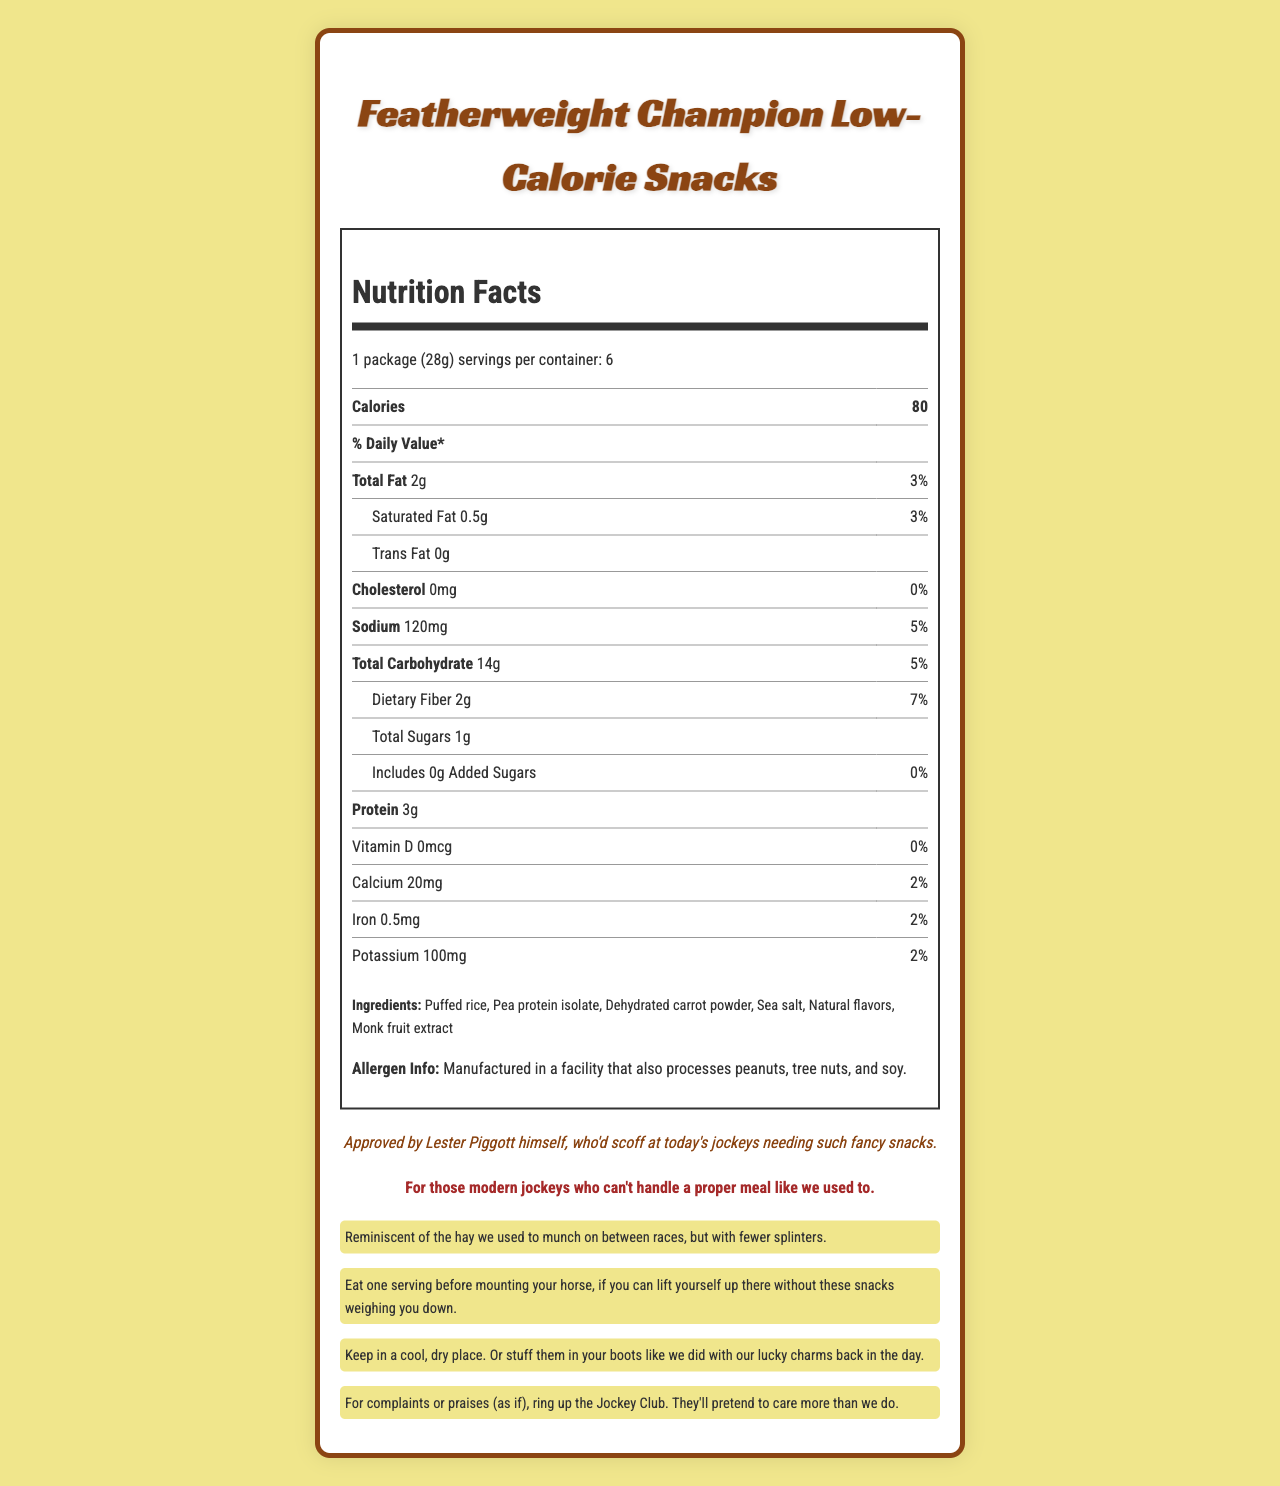who approved these low-calorie snacks? The document states, "Approved by Lester Piggott himself."
Answer: Lester Piggott how many servings are in one container? The document states that there are 6 servings per container.
Answer: 6 servings what is the serving size for these snacks? The document specifies the serving size as "1 package (28g)."
Answer: 1 package (28g) how much sodium is in one serving? The document lists the sodium content of one serving as 120mg.
Answer: 120mg what is the total fat content per serving? According to the document, the total fat content per serving is 2g.
Answer: 2g how much dietary fiber is in one serving of these snacks? The document states that one serving contains 2g of dietary fiber.
Answer: 2g how many calories are in one serving? The document lists the calorie content as 80 calories per serving.
Answer: 80 calories does this product contain any added sugars? The document shows that the added sugars amount is 0g, indicating no added sugars.
Answer: No which vitamin is not present in these snacks? A. Vitamin D B. Calcium C. Iron D. Potassium The document lists Vitamin D with 0mcg and a daily value of 0%.
Answer: A how much calcium is in one serving? The document states that one serving contains 20mg of calcium.
Answer: 20mg what should you do if you have a complaint about this product? A. Contact the manufacturer B. Ring the Jockey Club C. Write a review online D. Return to the store The document suggests, "For complaints or praises (as if), ring up the Jockey Club."
Answer: B do these snacks contain any cholesterol? The document states that the cholesterol content is 0mg.
Answer: No what is the nostalgic claim mentioned in the document? The document contains the nostalgic claim: "Reminiscent of the hay we used to munch on between races, but with fewer splinters."
Answer: Reminiscent of the hay we used to munch on between races, but with fewer splinters. describe the main idea of this document. The document presents information about the nutrition, serving size, and ingredients of the snacks, along with humorous and nostalgic remarks targeted at jockeys.
Answer: The document provides the nutrition facts, ingredient details, and promotional statements for "Featherweight Champion Low-Calorie Snacks," aimed at maintaining a race-ready physique, complete with sarcastic commentary and nostalgic claims. what are the main ingredients listed for these snacks? The document lists the ingredients as "Puffed rice, Pea protein isolate, Dehydrated carrot powder, Sea salt, Natural flavors, Monk fruit extract."
Answer: Puffed rice, Pea protein isolate, Dehydrated carrot powder, Sea salt, Natural flavors, Monk fruit extract is there any information about possible allergens? The document states that it is manufactured in a facility that also processes peanuts, tree nuts, and soy.
Answer: Yes what is the daily value percentage of dietary fiber in one serving? The document shows that the daily value percentage of dietary fiber is 7%.
Answer: 7% can we determine the exact number of packages required to reach 100 calories? The document only provides calorie information per package and per serving but does not easily allow calculation for non-integral package values.
Answer: No what should be the storage conditions for these snacks? The document advises keeping the snacks in a cool, dry place.
Answer: Keep in a cool, dry place. what is the sarcastic tagline mentioned in the document? The document contains the sarcastic tagline: "For those modern jockeys who can't handle a proper meal like we used to."
Answer: For those modern jockeys who can't handle a proper meal like we used to. 